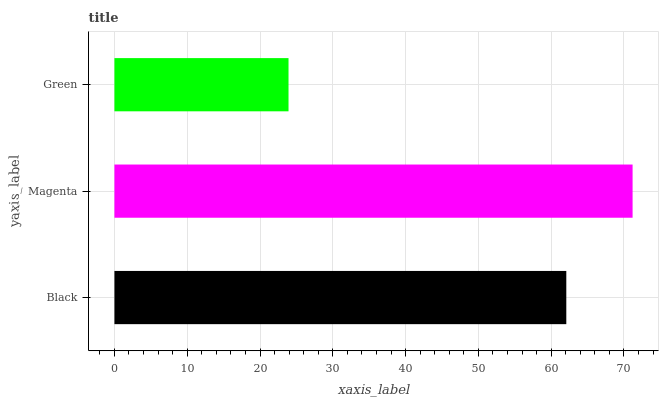Is Green the minimum?
Answer yes or no. Yes. Is Magenta the maximum?
Answer yes or no. Yes. Is Magenta the minimum?
Answer yes or no. No. Is Green the maximum?
Answer yes or no. No. Is Magenta greater than Green?
Answer yes or no. Yes. Is Green less than Magenta?
Answer yes or no. Yes. Is Green greater than Magenta?
Answer yes or no. No. Is Magenta less than Green?
Answer yes or no. No. Is Black the high median?
Answer yes or no. Yes. Is Black the low median?
Answer yes or no. Yes. Is Green the high median?
Answer yes or no. No. Is Magenta the low median?
Answer yes or no. No. 